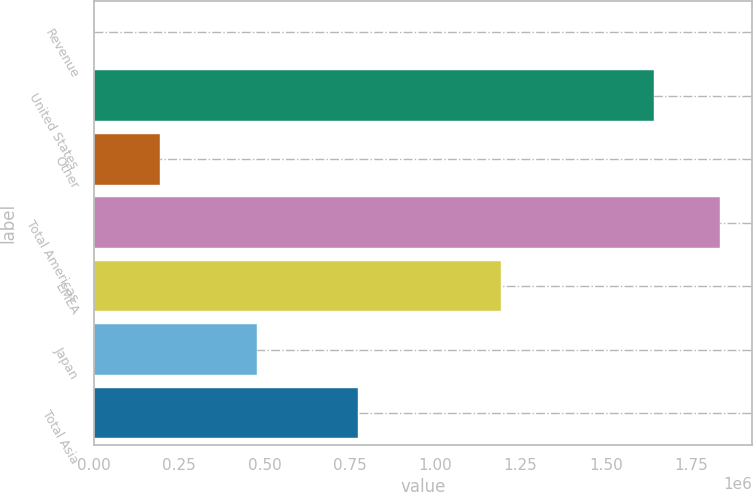Convert chart to OTSL. <chart><loc_0><loc_0><loc_500><loc_500><bar_chart><fcel>Revenue<fcel>United States<fcel>Other<fcel>Total Americas<fcel>EMEA<fcel>Japan<fcel>Total Asia<nl><fcel>2010<fcel>1.64198e+06<fcel>193309<fcel>1.83529e+06<fcel>1.19195e+06<fcel>477462<fcel>772760<nl></chart> 